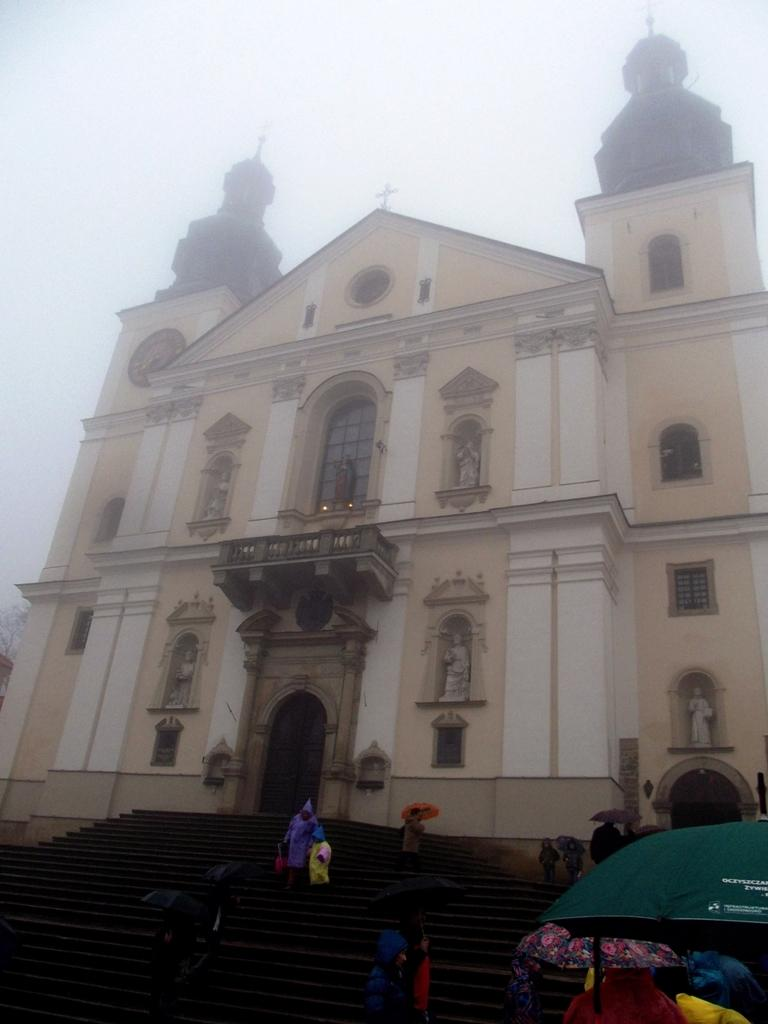What type of structure is visible in the image? There is a building in the image. What features can be observed on the building? The building has windows and stairs. What are the people in the image wearing? The people are wearing raincoats in the image. What do the people have with them? The people are carrying umbrellas. How would you describe the weather in the image? The sky is foggy in the image. What type of egg is being used for the treatment in the image? There is no egg or treatment present in the image; it features a building with people wearing raincoats and carrying umbrellas. What kind of paste is being applied to the building in the image? There is no paste being applied to the building in the image; it only shows the building's features and the people nearby. 